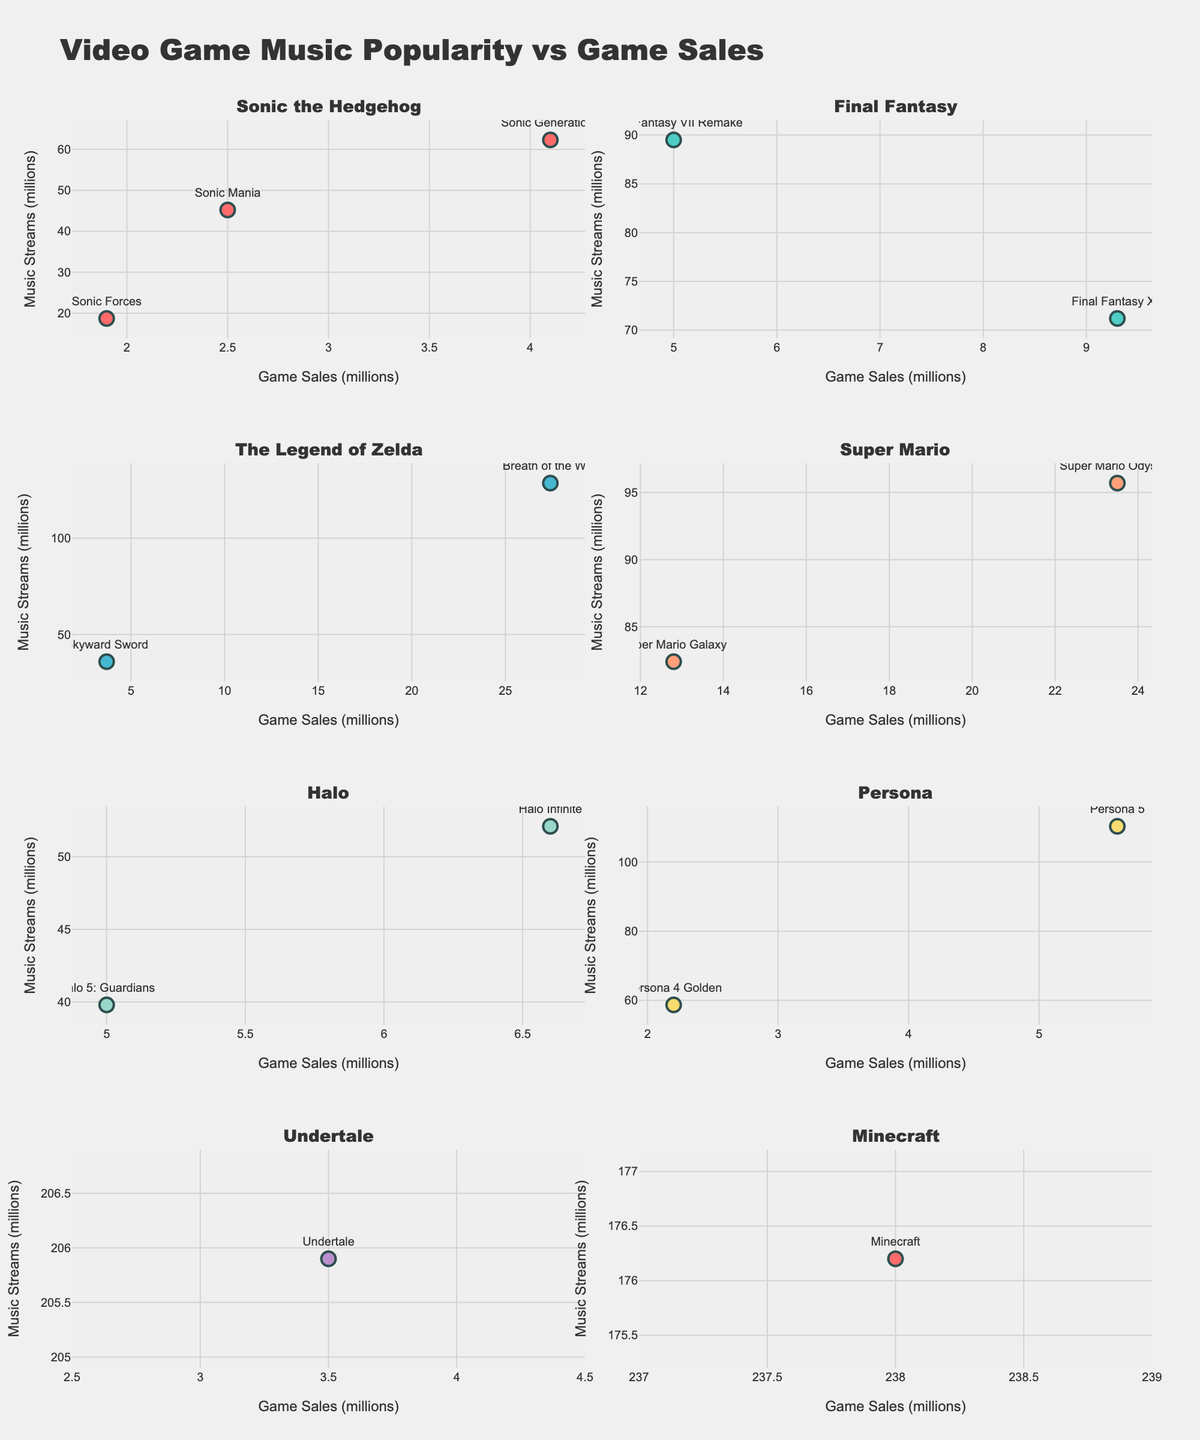How many data points are representing the "Sonic the Hedgehog" franchise? By observing the figure, count the number of data points labeled with game titles from the "Sonic the Hedgehog" franchise.
Answer: 3 Which franchise has the highest game sales figure and what is that figure? Look at the x-axis values and identify the highest game sales figure among all franchises. The "Minecraft" franchise has the highest figure with 238 million sales.
Answer: Minecraft, 238 million Is there any franchise that has a game with music streams exceeding 100 million but game sales are less than 10 million? If so, which game? Look at the plot and check for franchises with music streams above 100 million on the y-axis and game sales below 10 million on the x-axis, identify the corresponding game titles.
Answer: Persona 5 Which franchise has more consistent music streams across its games, "Final Fantasy" or "Halo"? Compare the spread of the data points for "Final Fantasy" and "Halo" on the y-axis. "Final Fantasy" has a larger spread, while "Halo" has values clustered closer together, indicating more consistency.
Answer: Halo What is the median music stream value for the "The Legend of Zelda" franchise? Identify the y-axis values for "The Legend of Zelda" (128.6M, 35.9M), arrange them in order, and find the middle value.
Answer: 82.25 million Which game has the highest ratio of music streams to game sales, and what is that ratio? For each game, divide the music streams value by the game sales value, and identify the game with the highest resulting ratio. "Undertale" has the ratio of 205.9/3.5 ≈ 58.8.
Answer: Undertale, 58.8 Do games with higher music streams tend also to have higher game sales across all franchises? Compare the general trend of data points in each subplot; if points generally slope upwards to the right, it indicates a positive correlation between music streams and game sales.
Answer: No clear trend Which game in the "Super Mario" franchise has higher game sales, and what are the respective sales figures? Compare the x-axis values for "Super Mario Odyssey" (23.5M) and "Super Mario Galaxy" (12.8M) to identify the higher number.
Answer: Super Mario Odyssey, 23.5 million What is the total number of music streams for "Persona" franchise games? Sum the y-axis values for "Persona" franchise games: 110.3M (Persona 5) and 58.7M (Persona 4 Golden).
Answer: 169 million 